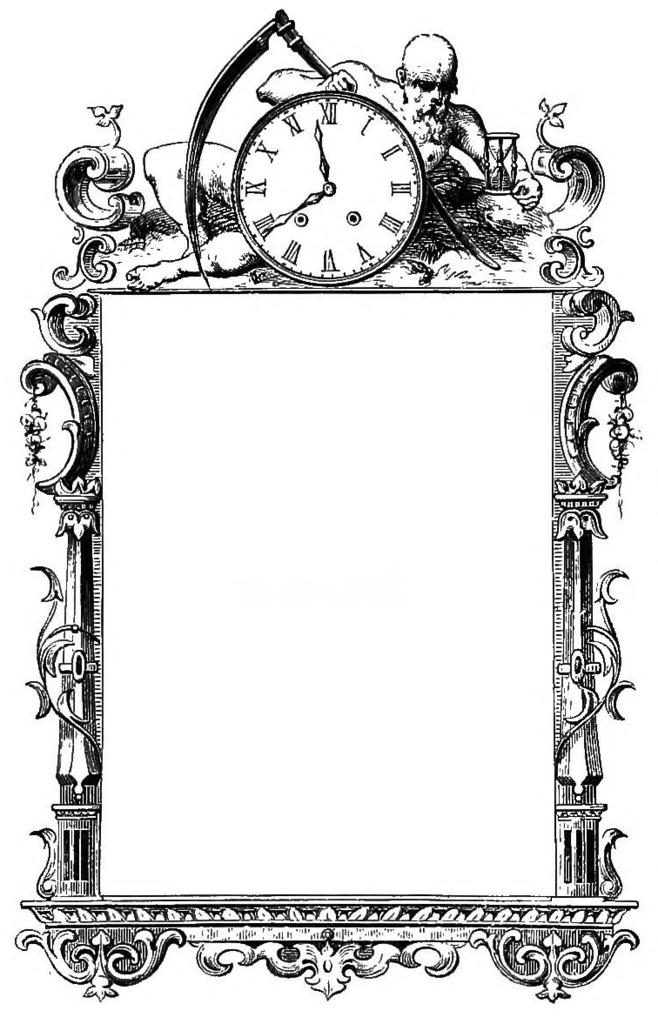What is the color scheme of the picture? The picture is black and white. What can be seen inside the frame in the picture? There is a clock on the frame in the picture. What part of the body is visible in the picture? There are no body parts visible in the picture; it features a black and white frame with a clock on it. Can you describe the edge of the clock in the picture? There is no specific description of the clock's edge provided in the image, as it is a black and white image with a focus on the frame and clock. 